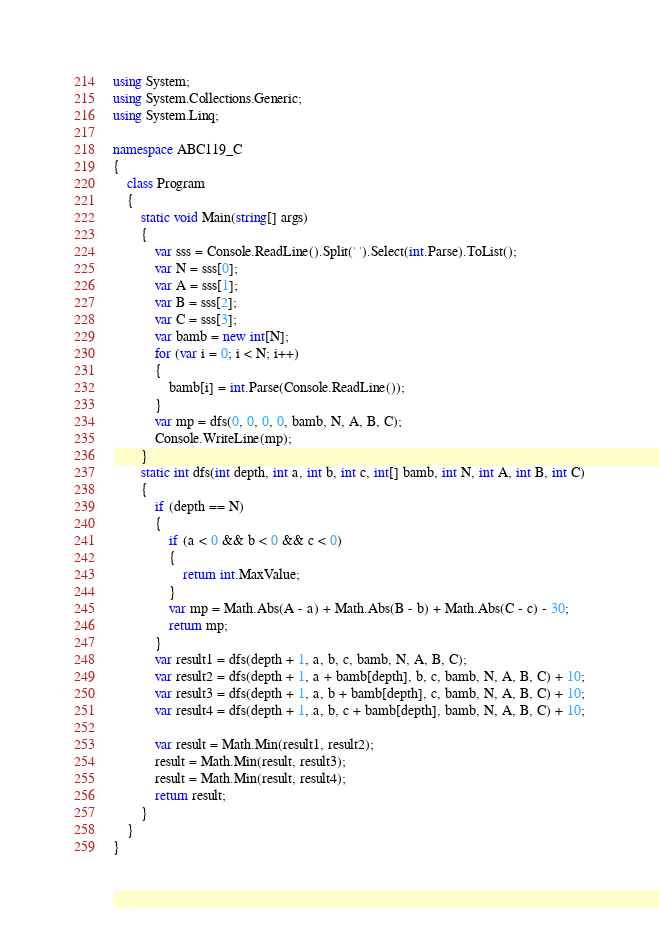<code> <loc_0><loc_0><loc_500><loc_500><_C#_>using System;
using System.Collections.Generic;
using System.Linq;

namespace ABC119_C
{
    class Program
    {
        static void Main(string[] args)
        {
            var sss = Console.ReadLine().Split(' ').Select(int.Parse).ToList();
            var N = sss[0];
            var A = sss[1];
            var B = sss[2];
            var C = sss[3];
            var bamb = new int[N];
            for (var i = 0; i < N; i++)
            {
                bamb[i] = int.Parse(Console.ReadLine());
            }
            var mp = dfs(0, 0, 0, 0, bamb, N, A, B, C);
            Console.WriteLine(mp);
        }
        static int dfs(int depth, int a, int b, int c, int[] bamb, int N, int A, int B, int C)
        {
            if (depth == N)
            {
                if (a < 0 && b < 0 && c < 0)
                {
                    return int.MaxValue;
                }
                var mp = Math.Abs(A - a) + Math.Abs(B - b) + Math.Abs(C - c) - 30;
                return mp;
            }
            var result1 = dfs(depth + 1, a, b, c, bamb, N, A, B, C);
            var result2 = dfs(depth + 1, a + bamb[depth], b, c, bamb, N, A, B, C) + 10;
            var result3 = dfs(depth + 1, a, b + bamb[depth], c, bamb, N, A, B, C) + 10;
            var result4 = dfs(depth + 1, a, b, c + bamb[depth], bamb, N, A, B, C) + 10;

            var result = Math.Min(result1, result2);
            result = Math.Min(result, result3);
            result = Math.Min(result, result4);
            return result;
        }
    }
}
</code> 